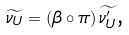<formula> <loc_0><loc_0><loc_500><loc_500>\widetilde { \nu _ { U } } = \left ( \beta \circ \pi \right ) \widetilde { \nu _ { U } ^ { \prime } } \text {,}</formula> 